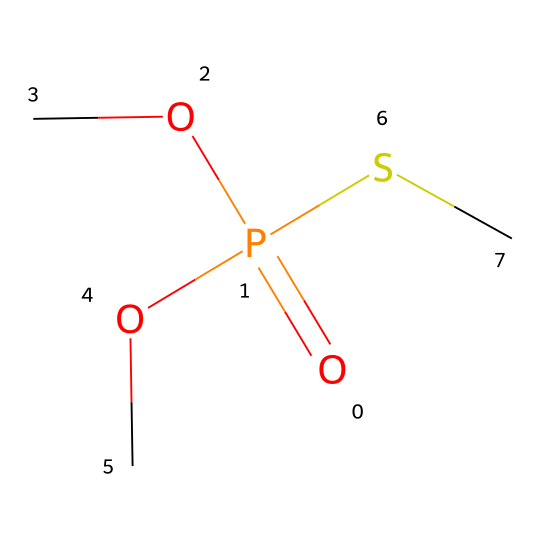What is the central atom in this compound? The central atom can be identified by locating the atom that forms the most bonds, which in this case is phosphorus (indicated by the "P" in the SMILES).
Answer: phosphorus How many oxygen atoms are present in the structure? The structure contains three oxygen symbols (O), which can be identified in the SMILES representation.
Answer: three What type of bond is primarily formed by the phosphorus atom in the compound? Phosphorus in hypervalent compounds typically forms covalent bonds with the surrounding atoms, and in this case, it is depicted as forming three bonds with oxygen, indicating covalent bonding.
Answer: covalent What functional groups are present in this compound? The presence of -O and -S in the SMILES indicates the presence of alkoxy (due to OC groups) and thioether functionality (due to the SC group).
Answer: alkoxy and thioether Does this compound contain any thiol groups? A thiol group would typically feature a sulfur directly bonded to a hydrogen (SH). Here, the sulfur is bonded to a carbon (SC), indicating the absence of a thiol group.
Answer: no How many total valence electrons does the central phosphorus atom utilize here? Phosphorus has five valence electrons and uses them to form bonds with three oxygen atoms and one sulfur, indicating it has an expanded octet, utilizing all five of its electrons.
Answer: five Is this compound likely to be a solid or a liquid at room temperature? Organophosphate pesticides are generally liquid due to being low-molecular-weight compounds, as indicated by the structures and properties typical of such compounds.
Answer: liquid 